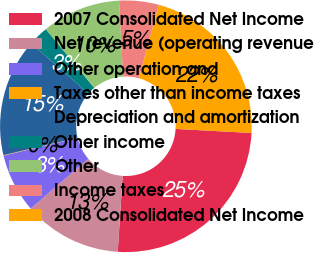<chart> <loc_0><loc_0><loc_500><loc_500><pie_chart><fcel>2007 Consolidated Net Income<fcel>Net revenue (operating revenue<fcel>Other operation and<fcel>Taxes other than income taxes<fcel>Depreciation and amortization<fcel>Other income<fcel>Other<fcel>Income taxes<fcel>2008 Consolidated Net Income<nl><fcel>25.19%<fcel>12.62%<fcel>7.6%<fcel>0.06%<fcel>15.14%<fcel>2.57%<fcel>10.11%<fcel>5.08%<fcel>21.64%<nl></chart> 